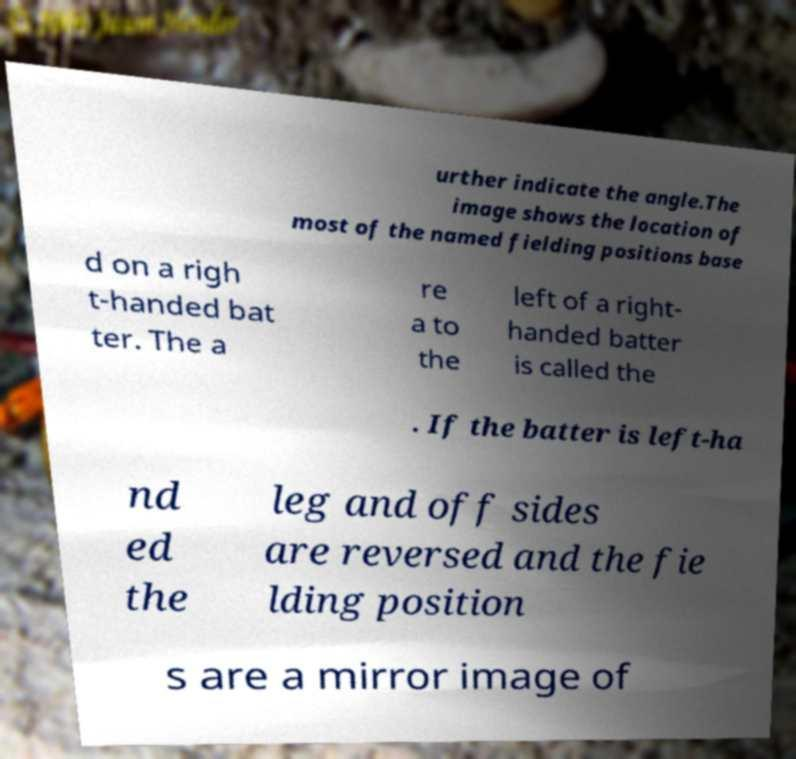Could you extract and type out the text from this image? urther indicate the angle.The image shows the location of most of the named fielding positions base d on a righ t-handed bat ter. The a re a to the left of a right- handed batter is called the . If the batter is left-ha nd ed the leg and off sides are reversed and the fie lding position s are a mirror image of 